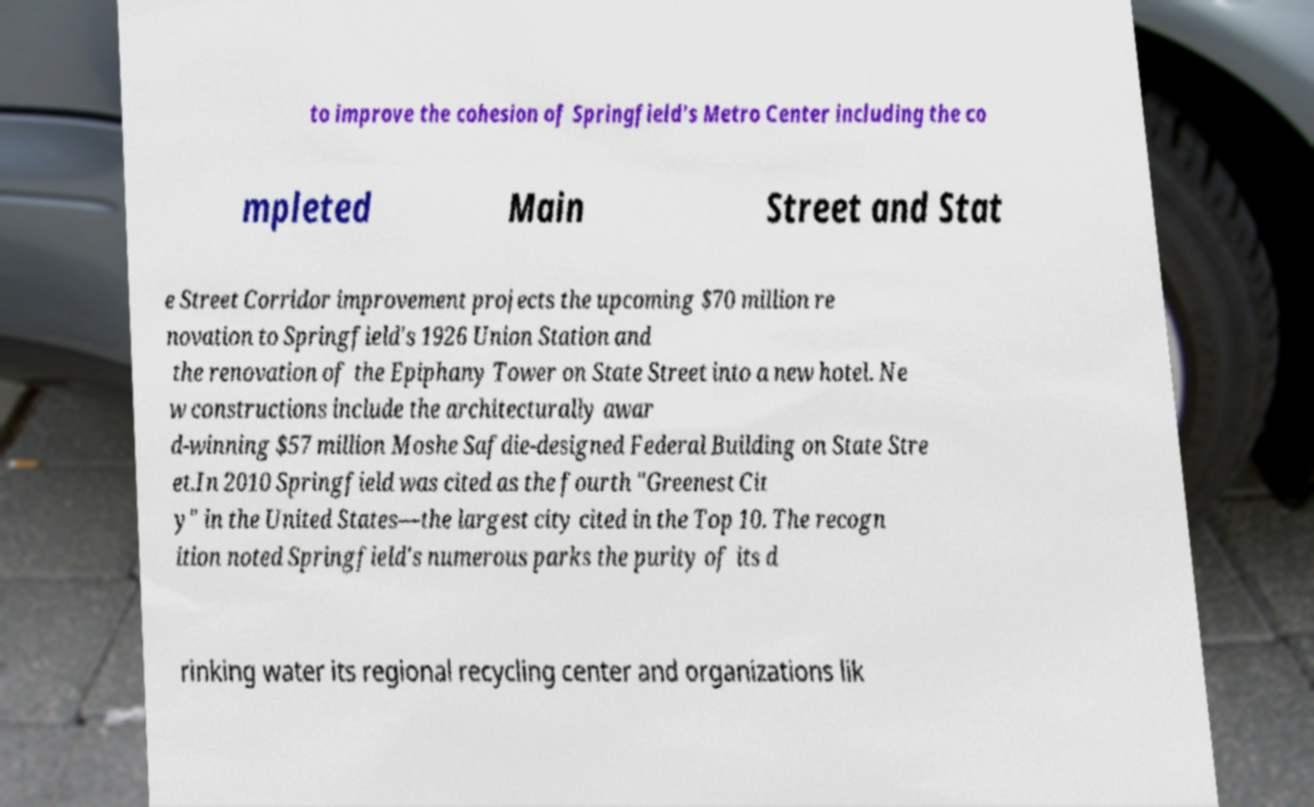I need the written content from this picture converted into text. Can you do that? to improve the cohesion of Springfield's Metro Center including the co mpleted Main Street and Stat e Street Corridor improvement projects the upcoming $70 million re novation to Springfield's 1926 Union Station and the renovation of the Epiphany Tower on State Street into a new hotel. Ne w constructions include the architecturally awar d-winning $57 million Moshe Safdie-designed Federal Building on State Stre et.In 2010 Springfield was cited as the fourth "Greenest Cit y" in the United States—the largest city cited in the Top 10. The recogn ition noted Springfield's numerous parks the purity of its d rinking water its regional recycling center and organizations lik 